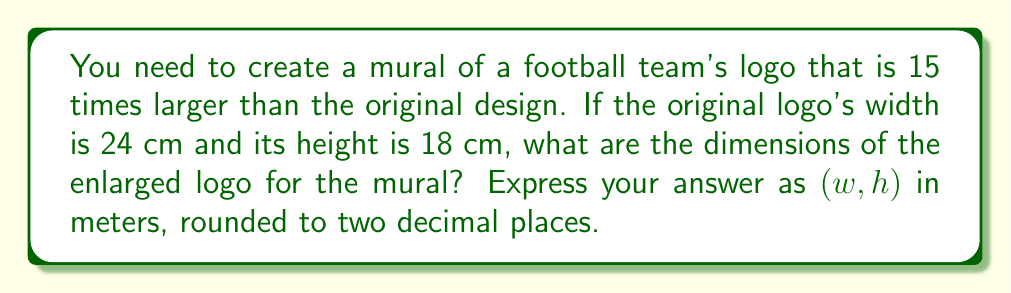Give your solution to this math problem. To solve this problem, we need to follow these steps:

1) First, let's identify the scaling factor:
   Scaling factor = 15

2) Now, let's calculate the new dimensions:

   For width:
   $$w_{new} = 24 \text{ cm} \times 15 = 360 \text{ cm}$$

   For height:
   $$h_{new} = 18 \text{ cm} \times 15 = 270 \text{ cm}$$

3) Convert the dimensions from centimeters to meters:
   
   For width:
   $$w_{meters} = 360 \text{ cm} \times \frac{1 \text{ m}}{100 \text{ cm}} = 3.60 \text{ m}$$

   For height:
   $$h_{meters} = 270 \text{ cm} \times \frac{1 \text{ m}}{100 \text{ cm}} = 2.70 \text{ m}$$

4) Round to two decimal places:
   Width: 3.60 m (already at two decimal places)
   Height: 2.70 m (already at two decimal places)

5) Express the answer as an ordered pair $(w, h)$ in meters:
   $(3.60, 2.70)$
Answer: $(3.60, 2.70)$ 